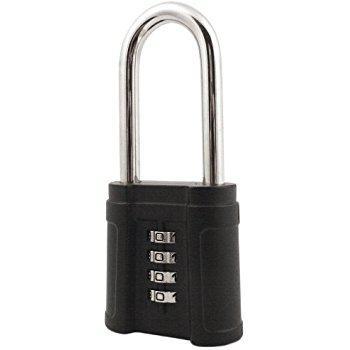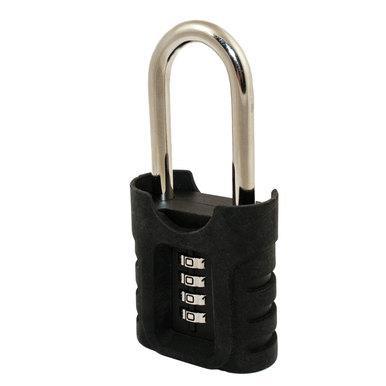The first image is the image on the left, the second image is the image on the right. Given the left and right images, does the statement "One of the locks is round in shape." hold true? Answer yes or no. No. The first image is the image on the left, the second image is the image on the right. For the images displayed, is the sentence "One lock is round with a black number dial, which the other is roughly square with four scrolling number belts." factually correct? Answer yes or no. No. 